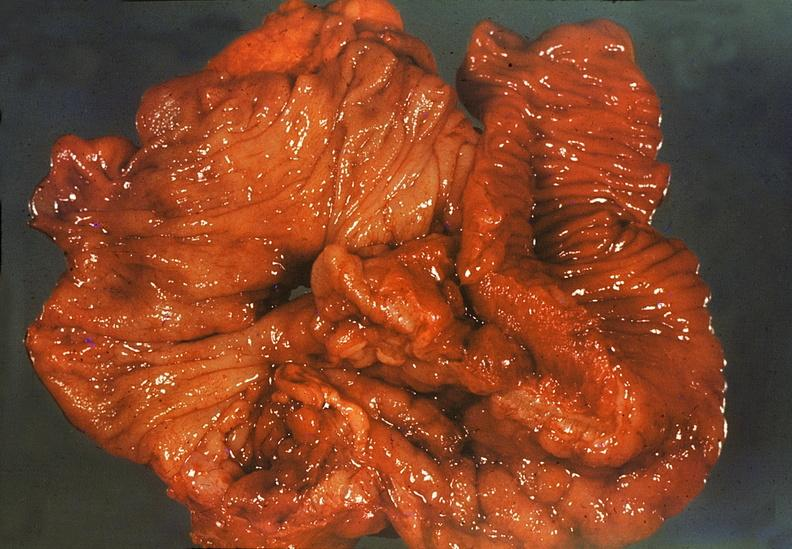does this image show ileum, regional enteritis?
Answer the question using a single word or phrase. Yes 